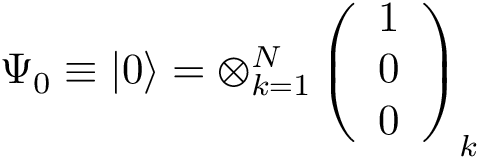<formula> <loc_0><loc_0><loc_500><loc_500>\Psi _ { 0 } \equiv \left | 0 \right \rangle = \otimes _ { k = 1 } ^ { N } \left ( \begin{array} { l } { 1 } \\ { 0 } \\ { 0 } \end{array} \right ) _ { k }</formula> 